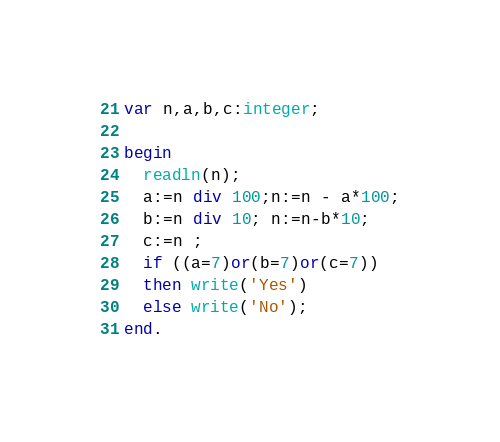Convert code to text. <code><loc_0><loc_0><loc_500><loc_500><_Pascal_>var n,a,b,c:integer;
 
begin
  readln(n);
  a:=n div 100;n:=n - a*100;
  b:=n div 10; n:=n-b*10;
  c:=n ;
  if ((a=7)or(b=7)or(c=7))
  then write('Yes')
  else write('No');
end.</code> 